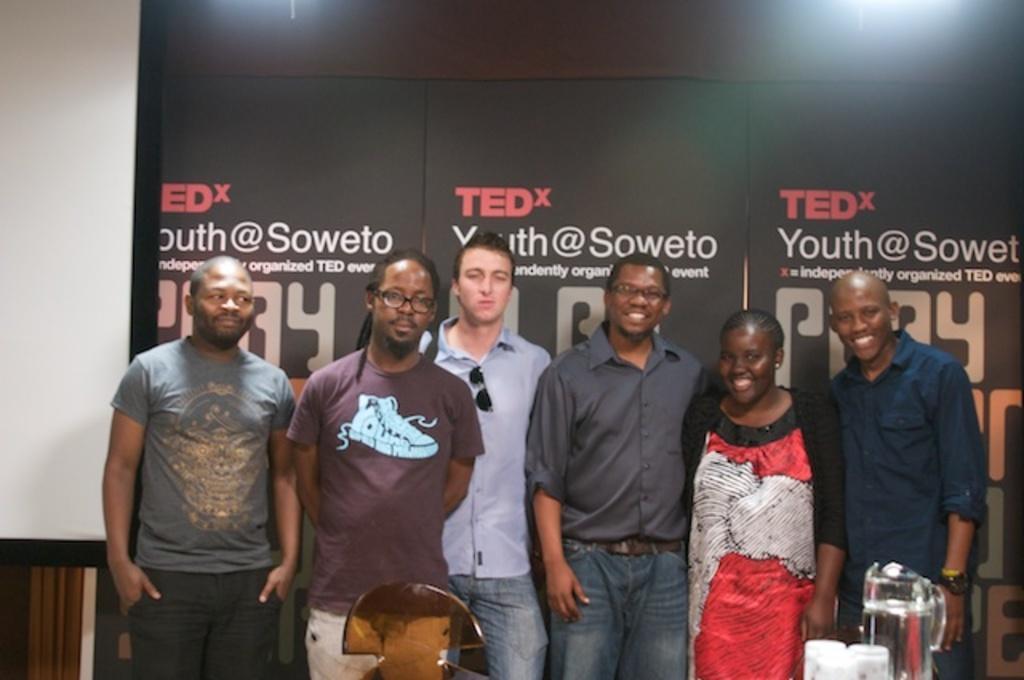Could you give a brief overview of what you see in this image? In this image I can see six persons are standing on the floor, mug and glasses. In the background I can see a wall, lights and hoardings. This image is taken may be in a hall. 